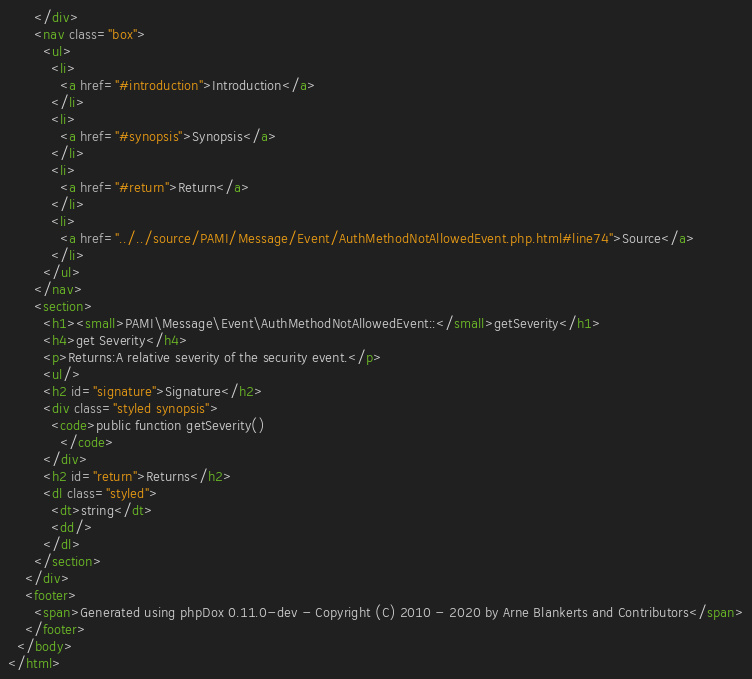Convert code to text. <code><loc_0><loc_0><loc_500><loc_500><_HTML_>      </div>
      <nav class="box">
        <ul>
          <li>
            <a href="#introduction">Introduction</a>
          </li>
          <li>
            <a href="#synopsis">Synopsis</a>
          </li>
          <li>
            <a href="#return">Return</a>
          </li>
          <li>
            <a href="../../source/PAMI/Message/Event/AuthMethodNotAllowedEvent.php.html#line74">Source</a>
          </li>
        </ul>
      </nav>
      <section>
        <h1><small>PAMI\Message\Event\AuthMethodNotAllowedEvent::</small>getSeverity</h1>
        <h4>get Severity</h4>
        <p>Returns:A relative severity of the security event.</p>
        <ul/>
        <h2 id="signature">Signature</h2>
        <div class="styled synopsis">
          <code>public function getSeverity()
            </code>
        </div>
        <h2 id="return">Returns</h2>
        <dl class="styled">
          <dt>string</dt>
          <dd/>
        </dl>
      </section>
    </div>
    <footer>
      <span>Generated using phpDox 0.11.0-dev - Copyright (C) 2010 - 2020 by Arne Blankerts and Contributors</span>
    </footer>
  </body>
</html>
</code> 